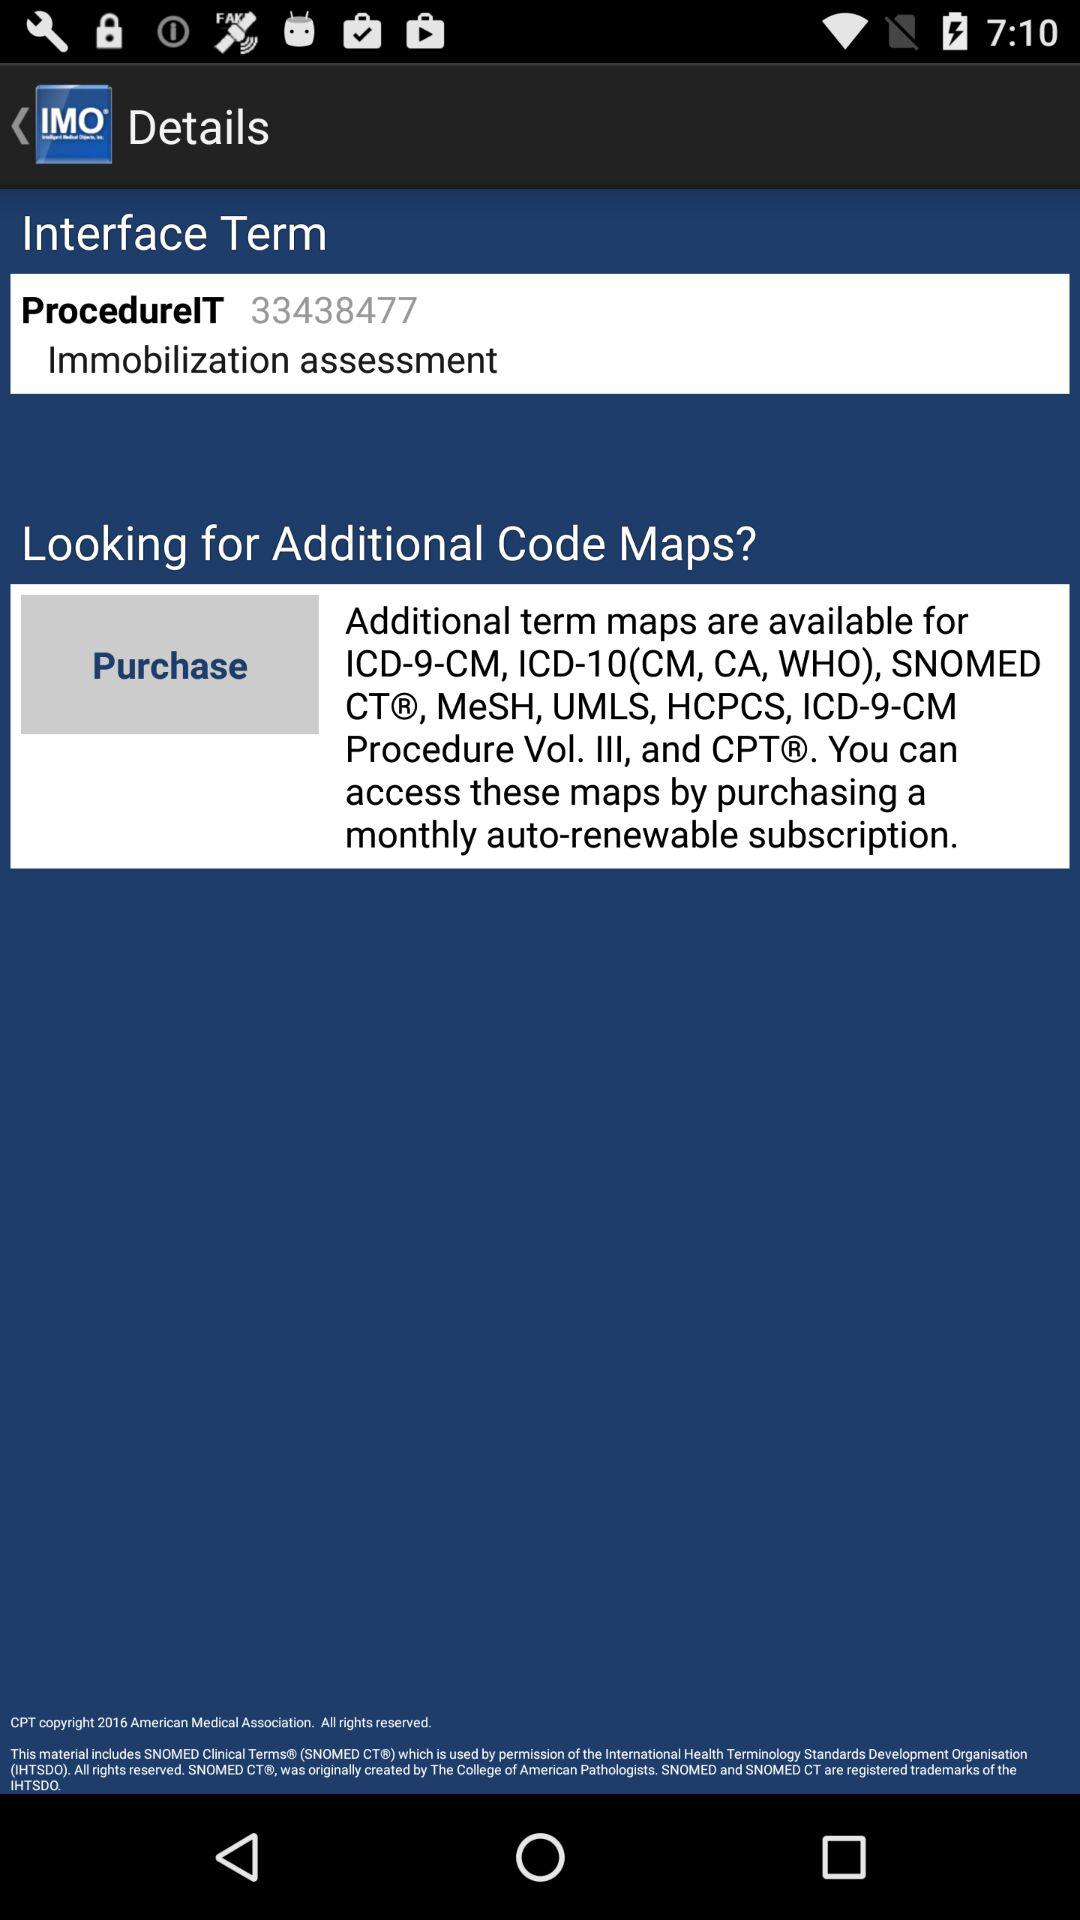What is the number for "ProcedureIT"? The number is 33438477. 